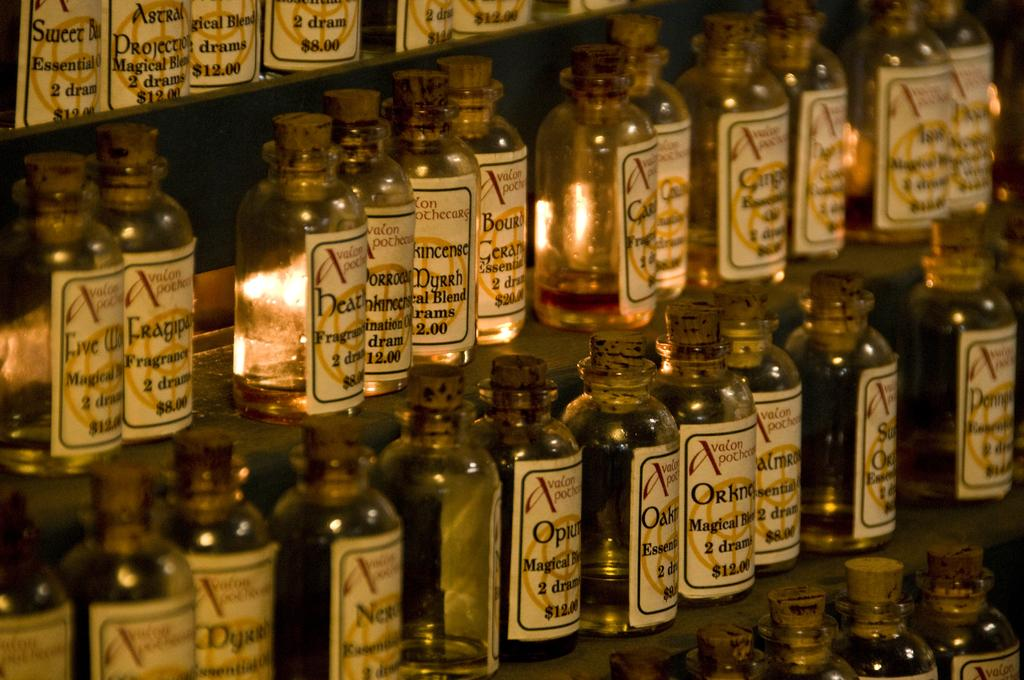<image>
Write a terse but informative summary of the picture. Many bottles for sale with the top left one being $12. 